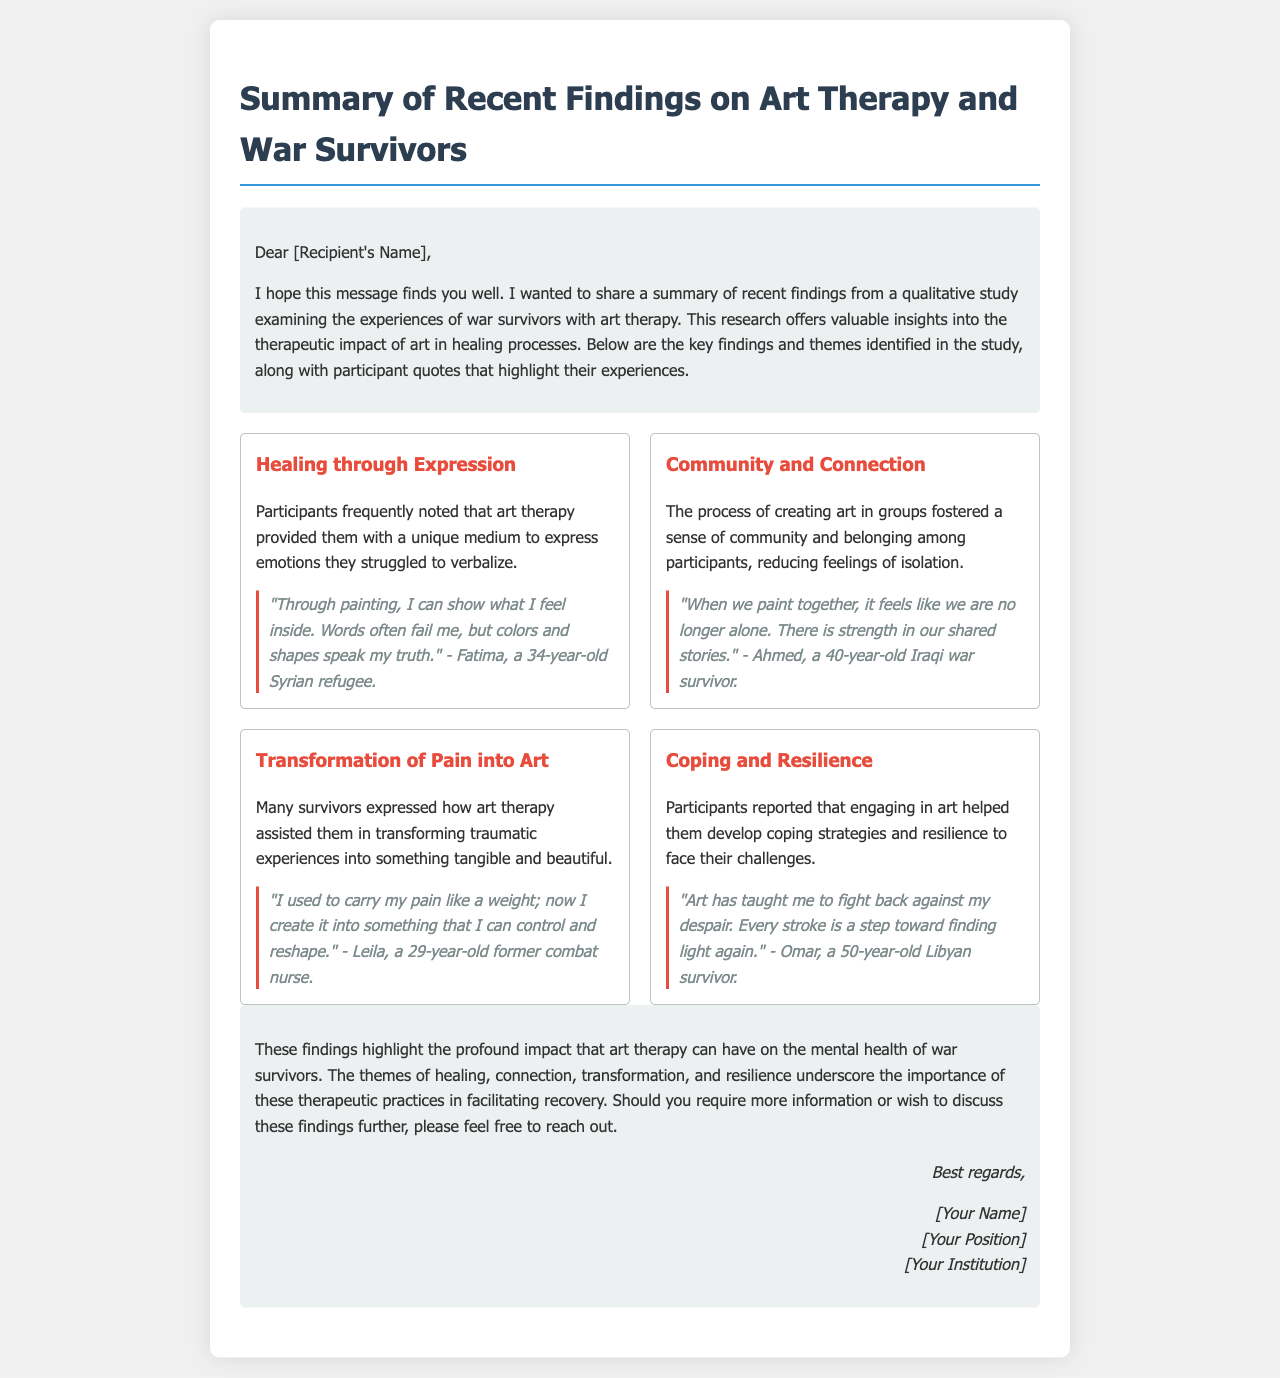What is the title of the document? The title is provided at the top of the document, indicating the focus of the findings on art therapy and war survivors.
Answer: Summary of Recent Findings on Art Therapy and War Survivors How many themes are identified in the findings? The document outlines four specific themes regarding the experiences of war survivors with art therapy.
Answer: Four Who is the participant that quoted about expressing feelings through painting? The quote about expressing feelings through painting is attributed to a particular participant included in the findings.
Answer: Fatima What feeling do participants report experiencing when creating art in groups? The document describes the feelings associated with group art creation, particularly regarding social connections and isolation.
Answer: Community and belonging What is one of the key themes related to coping strategies mentioned? The themes cover various aspects of recovery, including those relating to coping mechanisms against mental health challenges faced by war survivors.
Answer: Coping and Resilience Which participant talked about transforming pain into art? The document includes a specific quote from a participant discussing the transformation of trauma into art.
Answer: Leila 